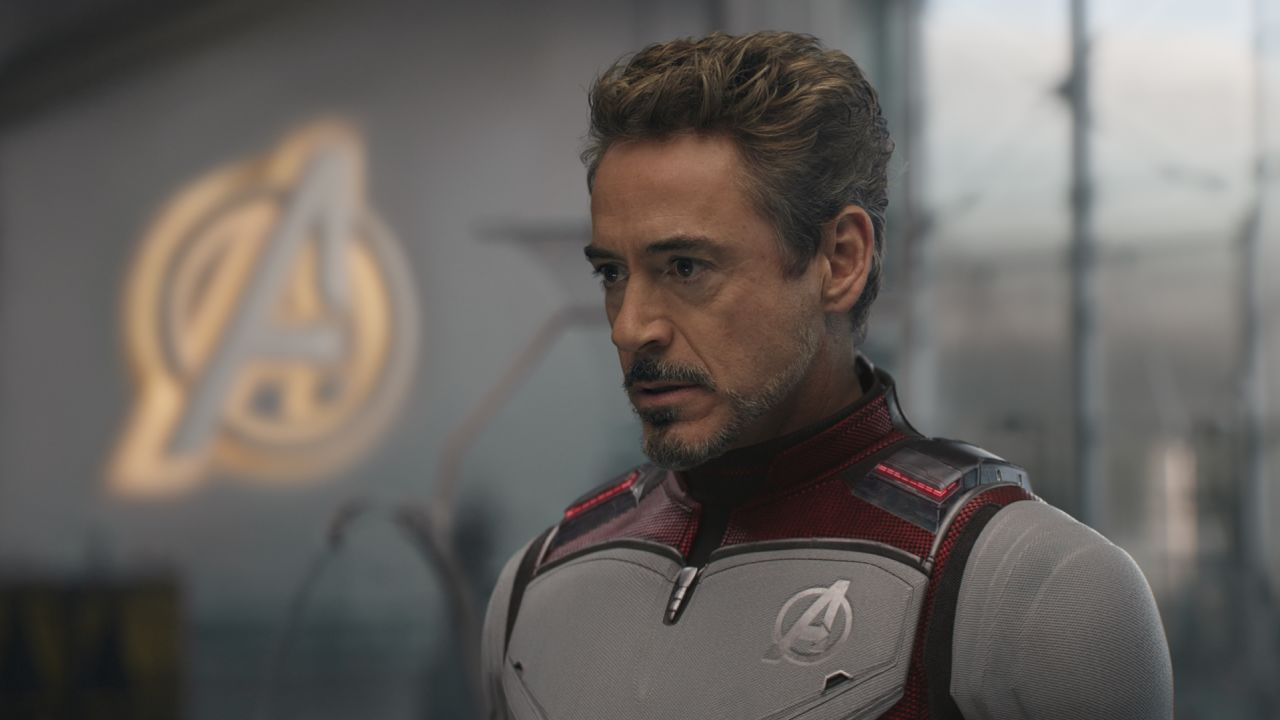How does this image relate to Tony Stark's character development in the series? This image captures a moment that hints at Tony Stark's evolution from a self-centered inventor to a dedicated and selfless hero. His somber demeanor and the strategic setting suggest his deep involvement and personal growth through the challenges faced by the Avengers, aligning with his journey towards becoming a true leader and protector. 